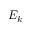<formula> <loc_0><loc_0><loc_500><loc_500>E _ { k }</formula> 